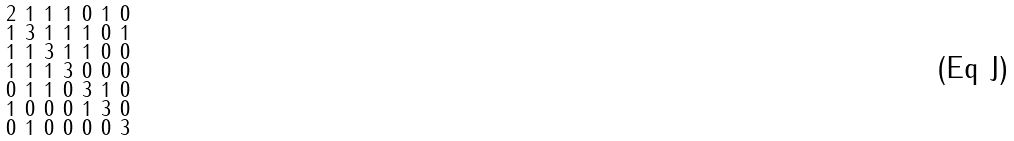<formula> <loc_0><loc_0><loc_500><loc_500>\begin{smallmatrix} 2 & 1 & 1 & 1 & 0 & 1 & 0 \\ 1 & 3 & 1 & 1 & 1 & 0 & 1 \\ 1 & 1 & 3 & 1 & 1 & 0 & 0 \\ 1 & 1 & 1 & 3 & 0 & 0 & 0 \\ 0 & 1 & 1 & 0 & 3 & 1 & 0 \\ 1 & 0 & 0 & 0 & 1 & 3 & 0 \\ 0 & 1 & 0 & 0 & 0 & 0 & 3 \end{smallmatrix}</formula> 